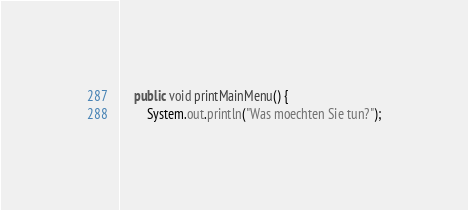Convert code to text. <code><loc_0><loc_0><loc_500><loc_500><_Java_>
	public void printMainMenu() {
		System.out.println("Was moechten Sie tun?");</code> 